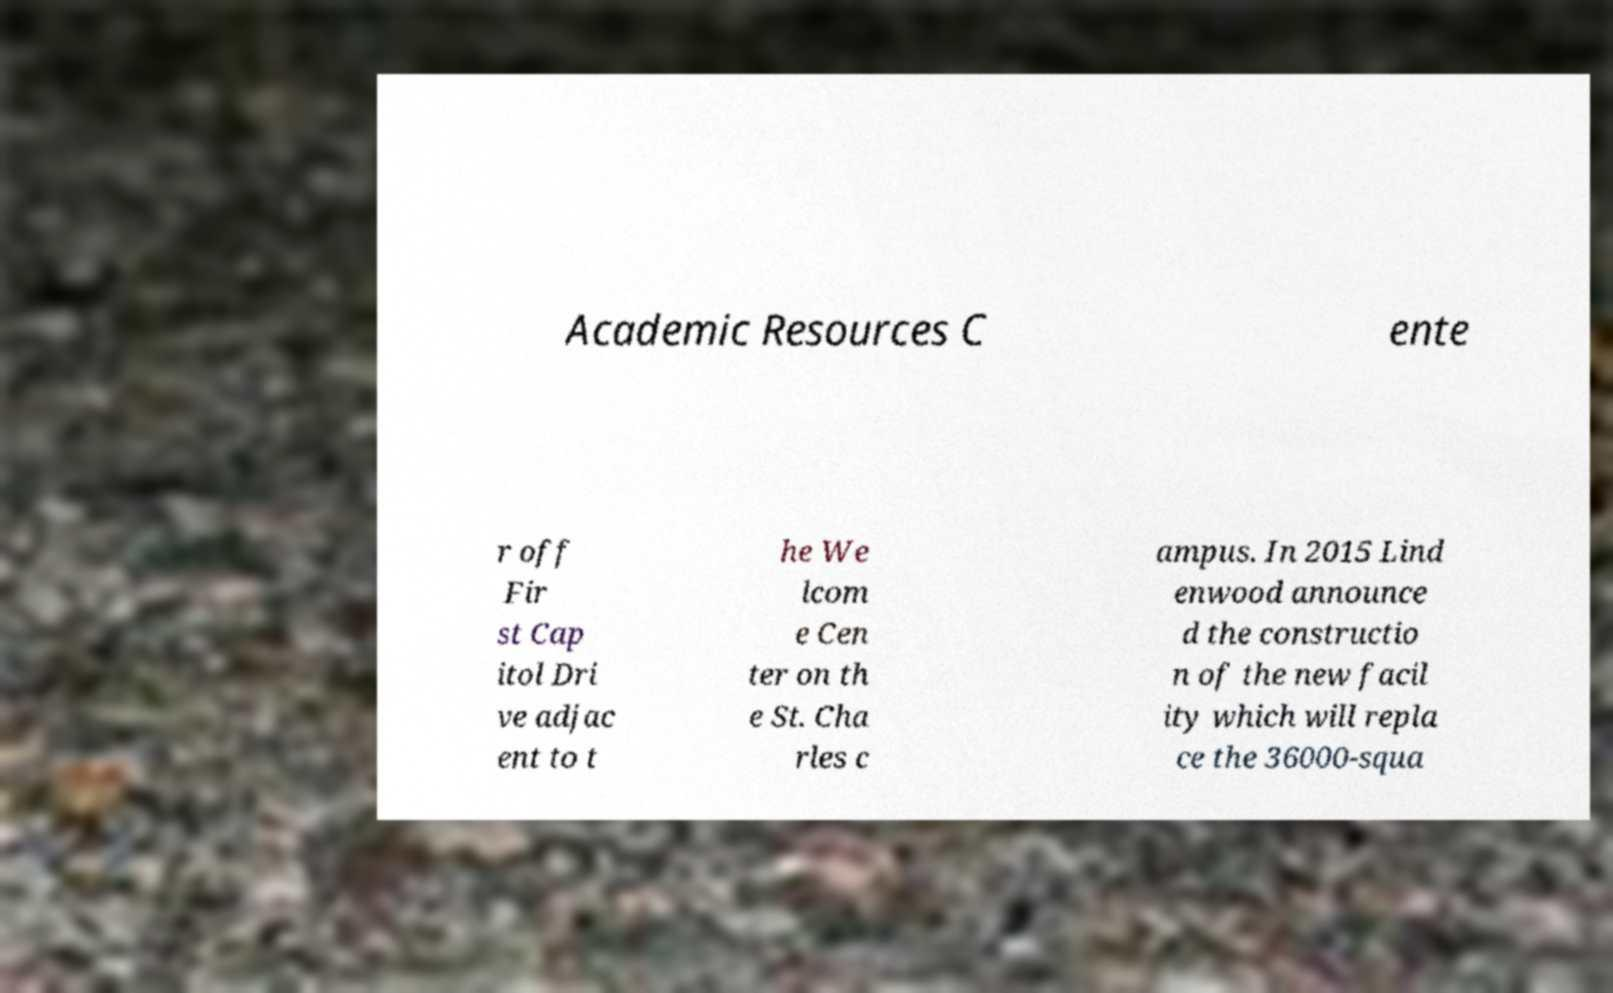Please identify and transcribe the text found in this image. Academic Resources C ente r off Fir st Cap itol Dri ve adjac ent to t he We lcom e Cen ter on th e St. Cha rles c ampus. In 2015 Lind enwood announce d the constructio n of the new facil ity which will repla ce the 36000-squa 